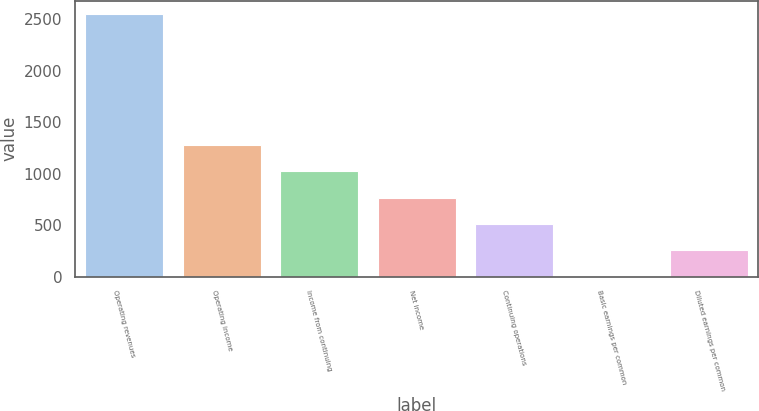Convert chart. <chart><loc_0><loc_0><loc_500><loc_500><bar_chart><fcel>Operating revenues<fcel>Operating income<fcel>Income from continuing<fcel>Net income<fcel>Continuing operations<fcel>Basic earnings per common<fcel>Diluted earnings per common<nl><fcel>2555<fcel>1277.75<fcel>1022.3<fcel>766.85<fcel>511.4<fcel>0.5<fcel>255.95<nl></chart> 